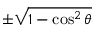Convert formula to latex. <formula><loc_0><loc_0><loc_500><loc_500>\pm { \sqrt { 1 - \cos ^ { 2 } \theta } }</formula> 